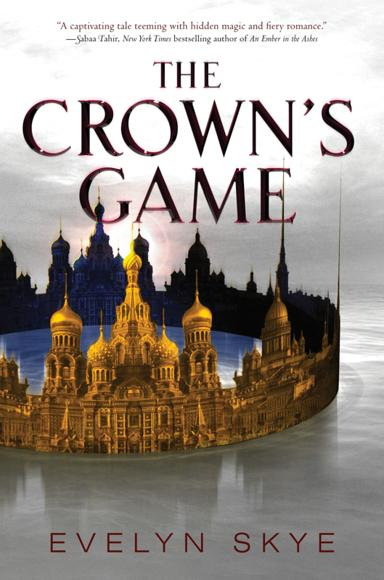What is the book title mentioned in the image? The book featured in the image is titled 'The Crown's Game' by Evelyn Skye. This novel invites readers into a captivating story set against a rich backdrop of imperial Russia, blending historical elements with enchanting magical battles. 